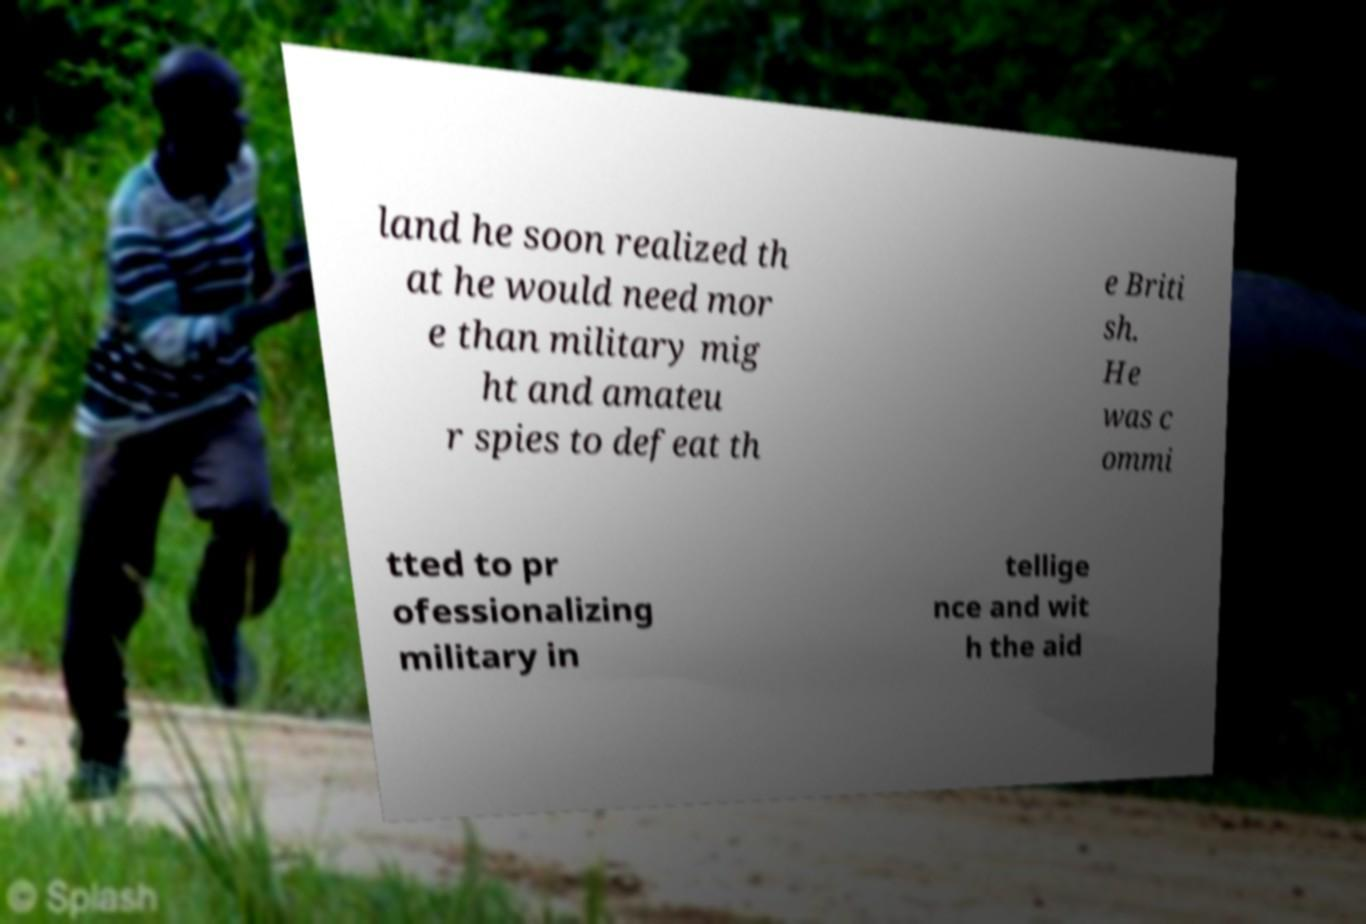Could you assist in decoding the text presented in this image and type it out clearly? land he soon realized th at he would need mor e than military mig ht and amateu r spies to defeat th e Briti sh. He was c ommi tted to pr ofessionalizing military in tellige nce and wit h the aid 